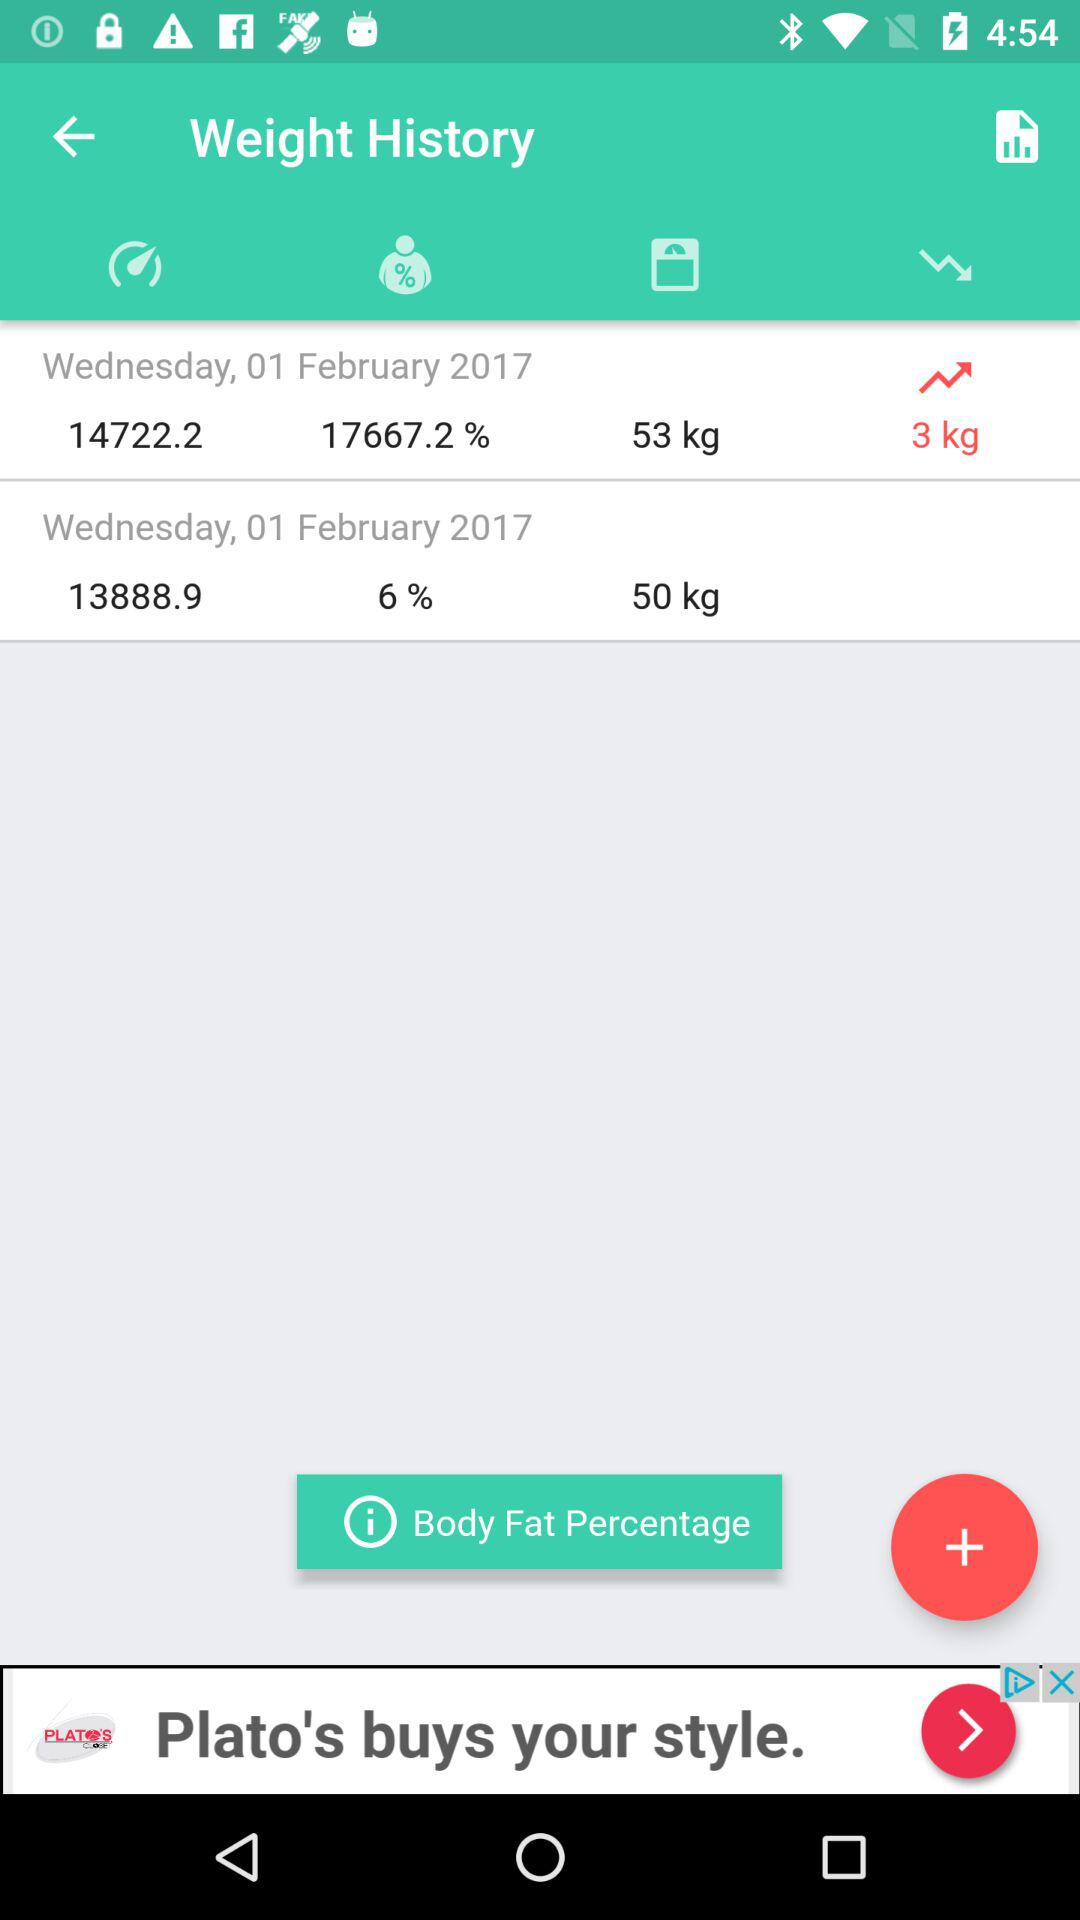What is the given body fat percentage? The given body fat percentages are 17667.2 and 6. 